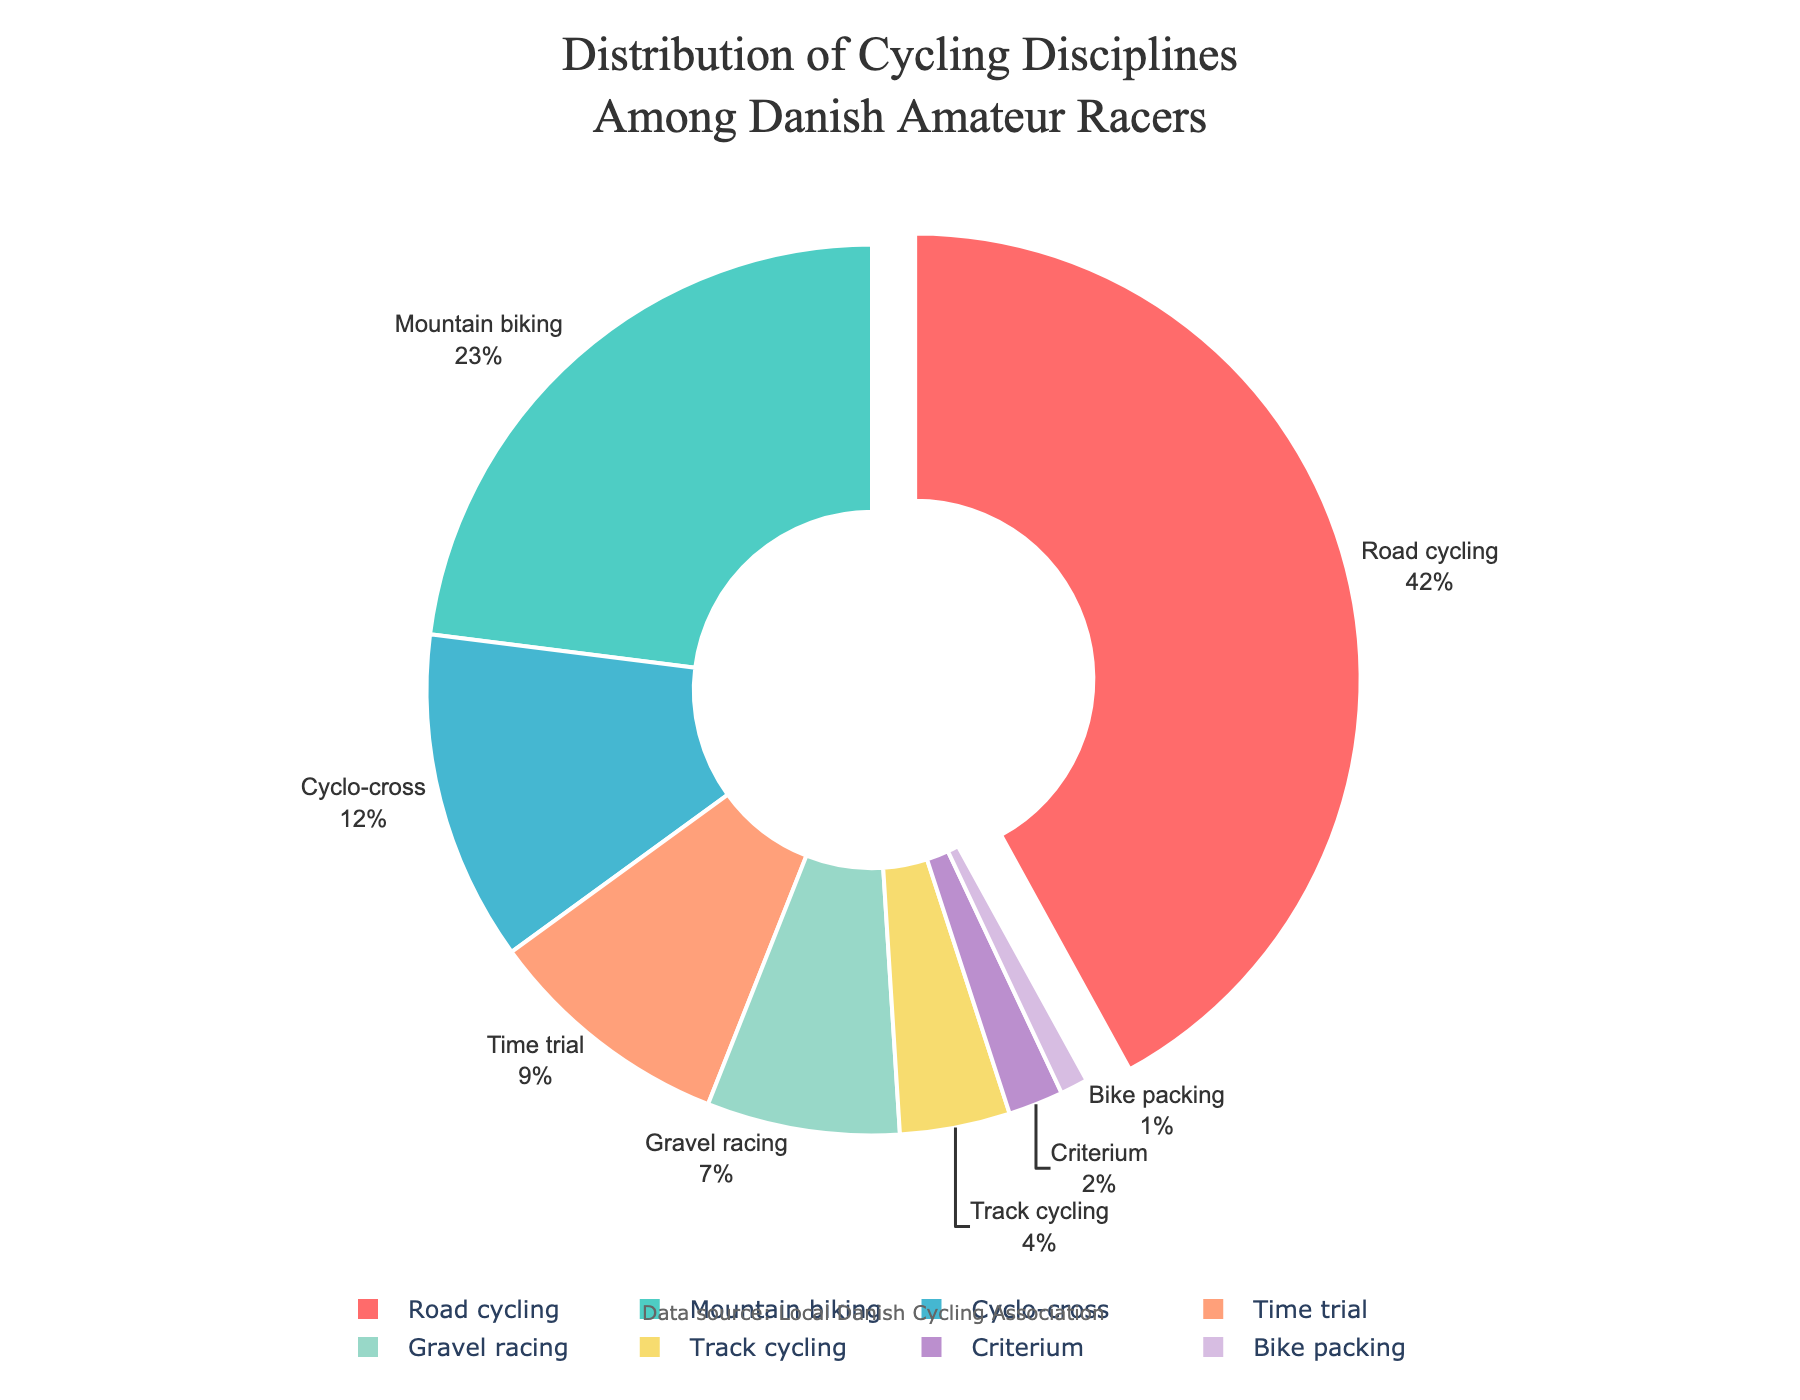What's the largest segment in the pie chart? The largest segment in the pie chart is the one with the highest percentage. In the pie chart, Road cycling has the highest percentage at 42%, making it the largest segment.
Answer: Road cycling What two segments together make up more than 50% of the total? To find the two segments that together make up more than 50%, look for the two largest percentages and sum them up. The two largest segments are Road cycling (42%) and Mountain biking (23%). Their combined percentage is 42% + 23% = 65%.
Answer: Road cycling and Mountain biking Which discipline has the smallest representation? The smallest segment in the pie chart is the one with the lowest percentage. In the pie chart, Bike packing has the smallest representation at 1%.
Answer: Bike packing How much greater is the percentage of Road cycling compared to Time trial? To find how much greater the percentage of Road cycling is compared to Time trial, subtract the percentage of Time trial from the percentage of Road cycling. Road cycling is 42% and Time trial is 9%, so the difference is 42% - 9% = 33%.
Answer: 33% Which two segments have the smallest difference in their percentages? To find the two segments with the smallest difference in their percentages, compare the percentages and find the smallest difference. Track cycling is 4% and Criterium is 2%, so their difference is 4% - 2% = 2%, which is the smallest difference compared to other segments.
Answer: Track cycling and Criterium If you combine the percentages of Cyclo-cross and Gravel racing, what percentage do you get? To combine the percentages of Cyclo-cross and Gravel racing, add their percentages together. Cyclo-cross is 12% and Gravel racing is 7%, so their combined percentage is 12% + 7% = 19%.
Answer: 19% What is the total percentage of disciplines other than Road cycling and Mountain biking? To find the total percentage of disciplines other than Road cycling and Mountain biking, first sum the percentages of all segments, which is 100%. Then subtract the percentages of Road cycling (42%) and Mountain biking (23%) from 100%. The total percentage is 100% - 42% - 23% = 35%.
Answer: 35% Which discipline is visually represented at the center of the pie chart with a hole? The discipline visually represented at the center of a pie chart with a hole is often marked by the pull effect or not having a pull at all. In this case, Road cycling has a pull effect and is the central representation due to its highest percentage.
Answer: Road cycling What is the combined percentage of Cyclo-cross, Time trial, and Gravel racing? To find the combined percentage of Cyclo-cross, Time trial, and Gravel racing, add their percentages together. Cyclo-cross is 12%, Time trial is 9%, and Gravel racing is 7%, so their combined percentage is 12% + 9% + 7% = 28%.
Answer: 28% How does the combined percentage of Track cycling and Criterium compare to the percentage of Cyclo-cross alone? To compare the combined percentage of Track cycling and Criterium to Cyclo-cross, add the percentages of Track cycling (4%) and Criterium (2%), which equals 6%. Cyclo-cross alone is 12%. Compare 6% with 12%, and the total of Track cycling and Criterium is smaller than Cyclo-cross.
Answer: Smaller 